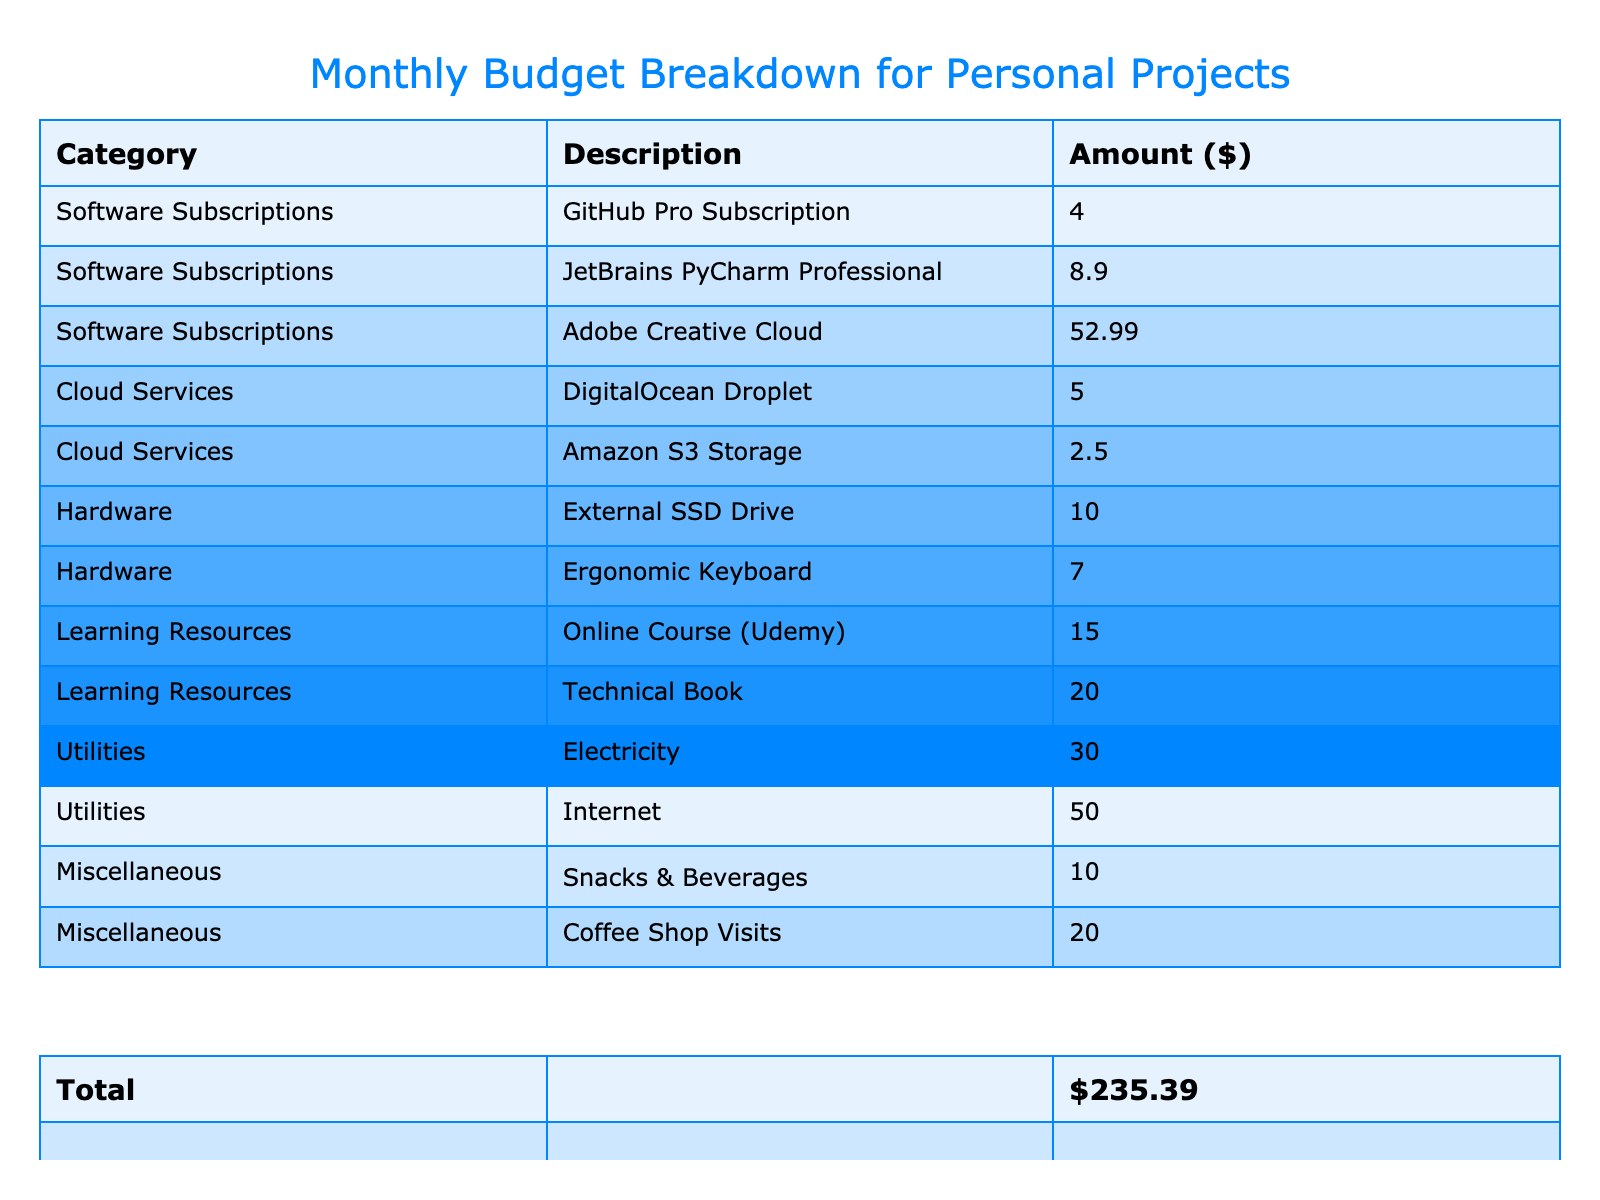What is the total amount spent on Software Subscriptions? To find the total amount for Software Subscriptions, we need to add the amounts for GitHub Pro Subscription (4), JetBrains PyCharm Professional (8.9), and Adobe Creative Cloud (52.99). The total is calculated as 4 + 8.9 + 52.99 = 65.89.
Answer: 65.89 Which category has the highest expenditure? By looking at the total amounts for each category, Software Subscriptions totals 65.89, Cloud Services totals 7.5, Hardware totals 17, Learning Resources totals 35, Utilities totals 80, and Miscellaneous totals 30. The highest expenditure category is Utilities with 80.
Answer: Utilities Is the amount spent on learning resources more than that spent on cloud services? Learning Resources amounts to 35 while Cloud Services totals 7.5. Since 35 is greater than 7.5, it is true that more is spent on learning resources.
Answer: Yes What is the average amount spent per category? There are 6 categories: Software Subscriptions, Cloud Services, Hardware, Learning Resources, Utilities, and Miscellaneous. The total amount is 65.89 + 7.5 + 17 + 35 + 80 + 30 = 235.39. We divide this total by 6 (the number of categories) to find the average: 235.39 / 6 = 39.23.
Answer: 39.23 How much is spent on Miscellaneous compared to Learning Resources? Miscellaneous totals 30 and Learning Resources totals 35. To compare, we can see that Learning Resources is greater by 35 - 30 = 5. Therefore, Miscellaneous is less than Learning Resources.
Answer: 5 less Is the combined amount for Utilities and Hardware greater than the total for Software Subscriptions? The combined amount for Utilities (80) and Hardware (17) is 80 + 17 = 97. Software Subscriptions totals 65.89. Since 97 is greater than 65.89, it shows that Utilities and Hardware combined exceed Software Subscriptions.
Answer: Yes How much would you have left if you spent the total amount on Utilities? If the total amount is 235.39 and the total spent on Utilities is 80, the remaining amount would be 235.39 - 80 = 155.39.
Answer: 155.39 What percentage of the total budget is spent on Snacks & Beverages? The total expenditure is 235.39 and the amount spent on Snacks & Beverages is 10. To find the percentage, we calculate (10 / 235.39) * 100 = approximately 4.25%.
Answer: 4.25% 